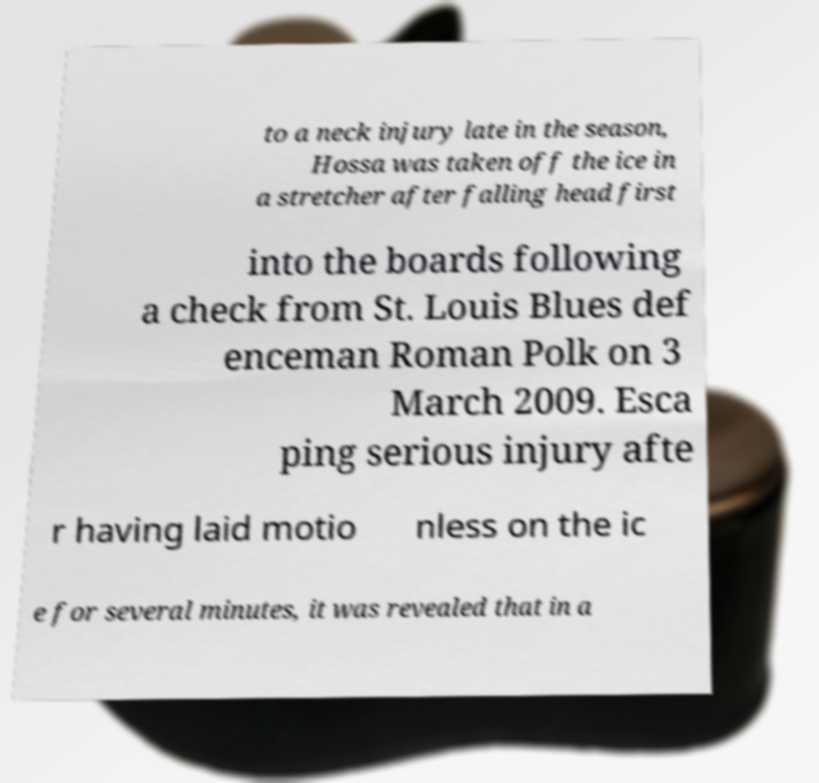Could you assist in decoding the text presented in this image and type it out clearly? to a neck injury late in the season, Hossa was taken off the ice in a stretcher after falling head first into the boards following a check from St. Louis Blues def enceman Roman Polk on 3 March 2009. Esca ping serious injury afte r having laid motio nless on the ic e for several minutes, it was revealed that in a 